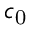Convert formula to latex. <formula><loc_0><loc_0><loc_500><loc_500>c _ { 0 }</formula> 